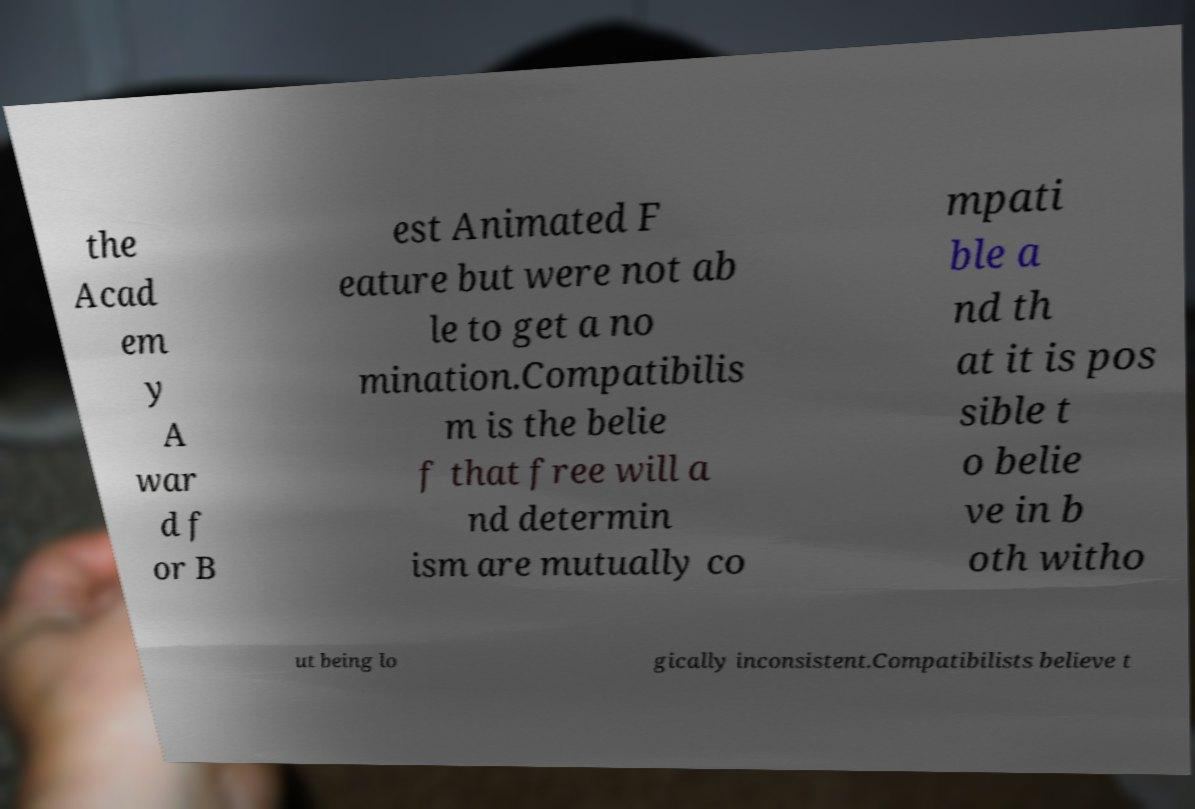What messages or text are displayed in this image? I need them in a readable, typed format. the Acad em y A war d f or B est Animated F eature but were not ab le to get a no mination.Compatibilis m is the belie f that free will a nd determin ism are mutually co mpati ble a nd th at it is pos sible t o belie ve in b oth witho ut being lo gically inconsistent.Compatibilists believe t 